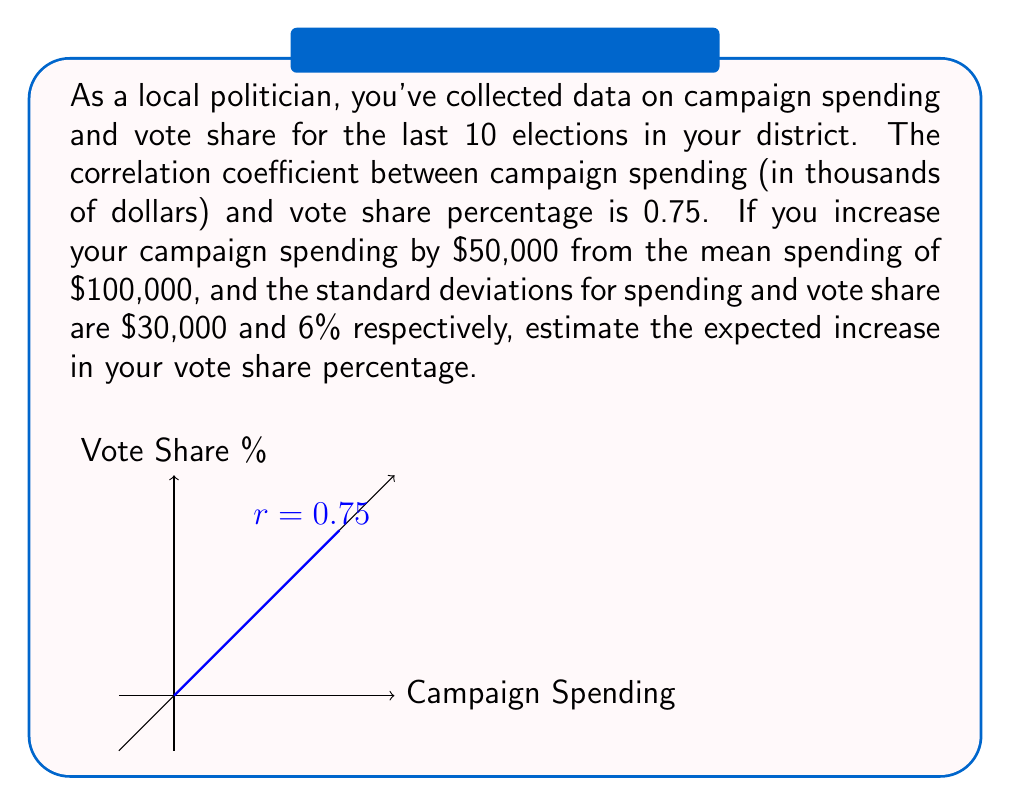Can you answer this question? Let's approach this step-by-step using the concept of correlation coefficients and linear regression:

1) The correlation coefficient (r) is given as 0.75.

2) We can use the formula for the slope of the regression line:

   $$b = r \cdot \frac{s_y}{s_x}$$

   where $b$ is the slope, $r$ is the correlation coefficient, $s_y$ is the standard deviation of y (vote share), and $s_x$ is the standard deviation of x (campaign spending).

3) Plugging in the values:

   $$b = 0.75 \cdot \frac{6}{30} = 0.75 \cdot 0.2 = 0.15$$

4) This means that for every thousand dollars increase in spending, we expect a 0.15 percentage point increase in vote share.

5) The proposed increase in spending is $50,000, which is 50 thousand dollars.

6) Therefore, the expected increase in vote share is:

   $$50 \cdot 0.15 = 7.5$$

So, we expect a 7.5 percentage point increase in vote share.
Answer: 7.5 percentage points 